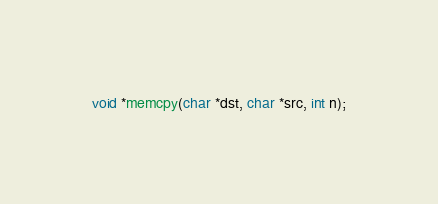<code> <loc_0><loc_0><loc_500><loc_500><_C_>

void *memcpy(char *dst, char *src, int n);</code> 